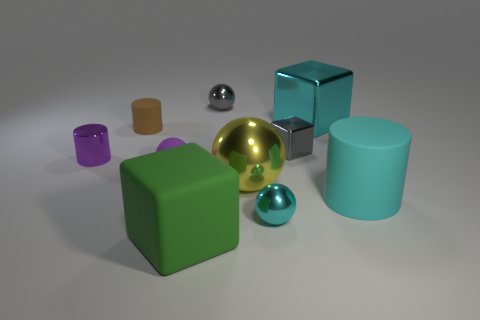Subtract all blue balls. Subtract all green cubes. How many balls are left? 4 Subtract all cubes. How many objects are left? 7 Add 5 small matte cylinders. How many small matte cylinders exist? 6 Subtract 0 yellow cylinders. How many objects are left? 10 Subtract all cyan metallic things. Subtract all small brown objects. How many objects are left? 7 Add 4 rubber blocks. How many rubber blocks are left? 5 